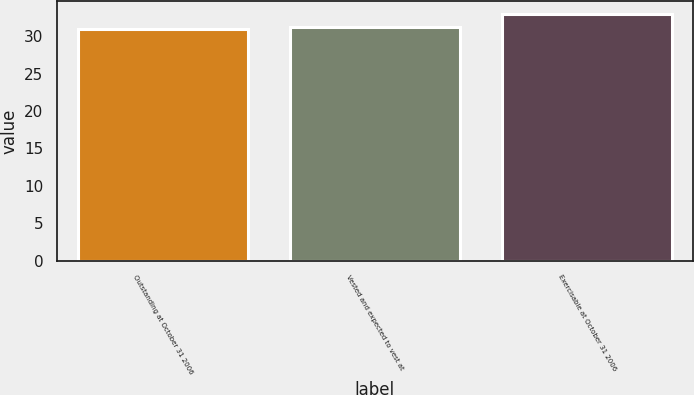Convert chart to OTSL. <chart><loc_0><loc_0><loc_500><loc_500><bar_chart><fcel>Outstanding at October 31 2006<fcel>Vested and expected to vest at<fcel>Exercisable at October 31 2006<nl><fcel>31<fcel>31.2<fcel>33<nl></chart> 